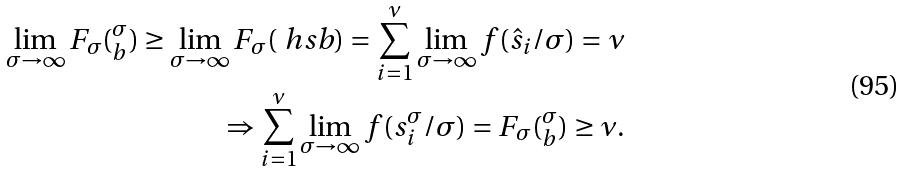Convert formula to latex. <formula><loc_0><loc_0><loc_500><loc_500>\lim _ { \sigma \to \infty } F _ { \sigma } ( _ { b } ^ { \sigma } ) \geq \lim _ { \sigma \to \infty } F _ { \sigma } ( \ h s b ) = \sum _ { i = 1 } ^ { \nu } \lim _ { \sigma \to \infty } f ( \hat { s } _ { i } / \sigma ) = \nu \\ \Rightarrow \sum _ { i = 1 } ^ { \nu } \lim _ { \sigma \to \infty } f ( s ^ { \sigma } _ { i } / \sigma ) = F _ { \sigma } ( _ { b } ^ { \sigma } ) \geq \nu .</formula> 